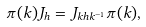<formula> <loc_0><loc_0><loc_500><loc_500>\pi ( k ) J _ { h } = J _ { k h k ^ { - 1 } } \pi ( k ) ,</formula> 